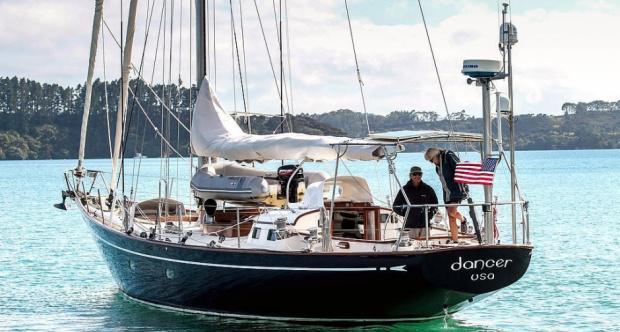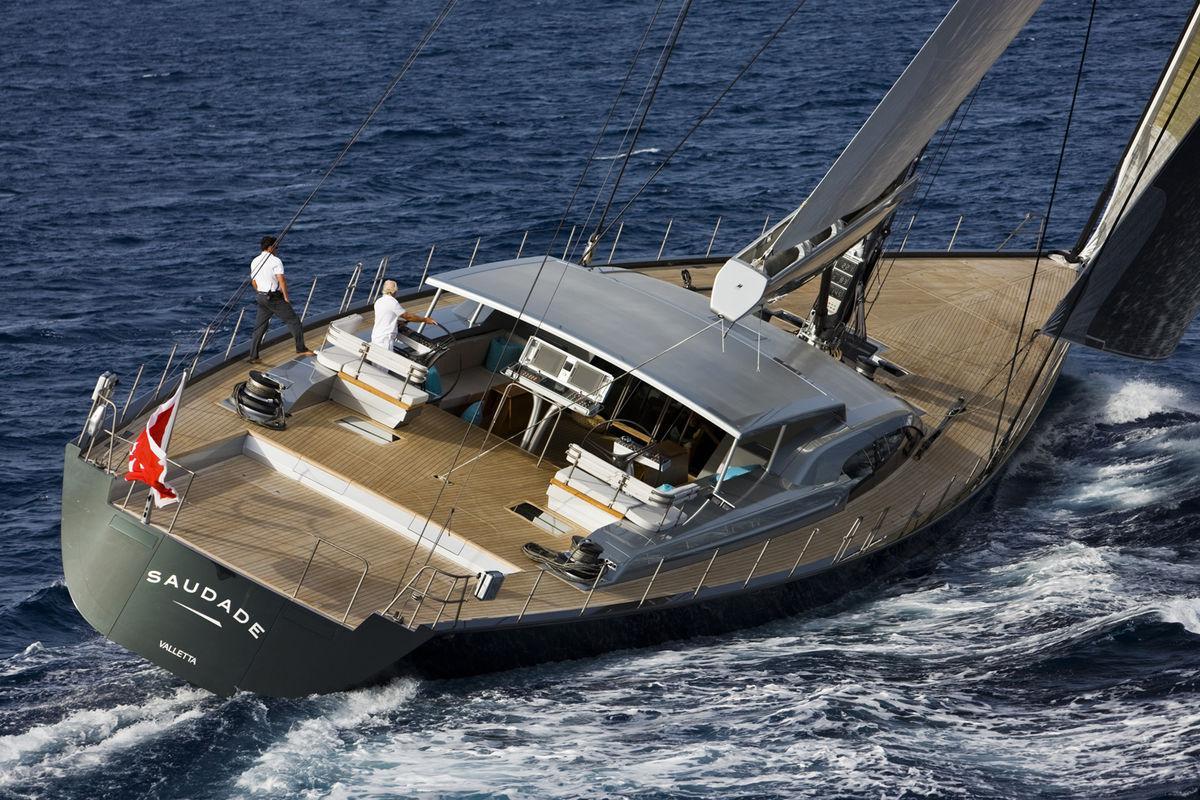The first image is the image on the left, the second image is the image on the right. Examine the images to the left and right. Is the description "The left image shows a boat with a dark exterior, furled sails and a flag at one end." accurate? Answer yes or no. Yes. The first image is the image on the left, the second image is the image on the right. Analyze the images presented: Is the assertion "The left and right image contains the same sailboat facing opposite directions." valid? Answer yes or no. No. 